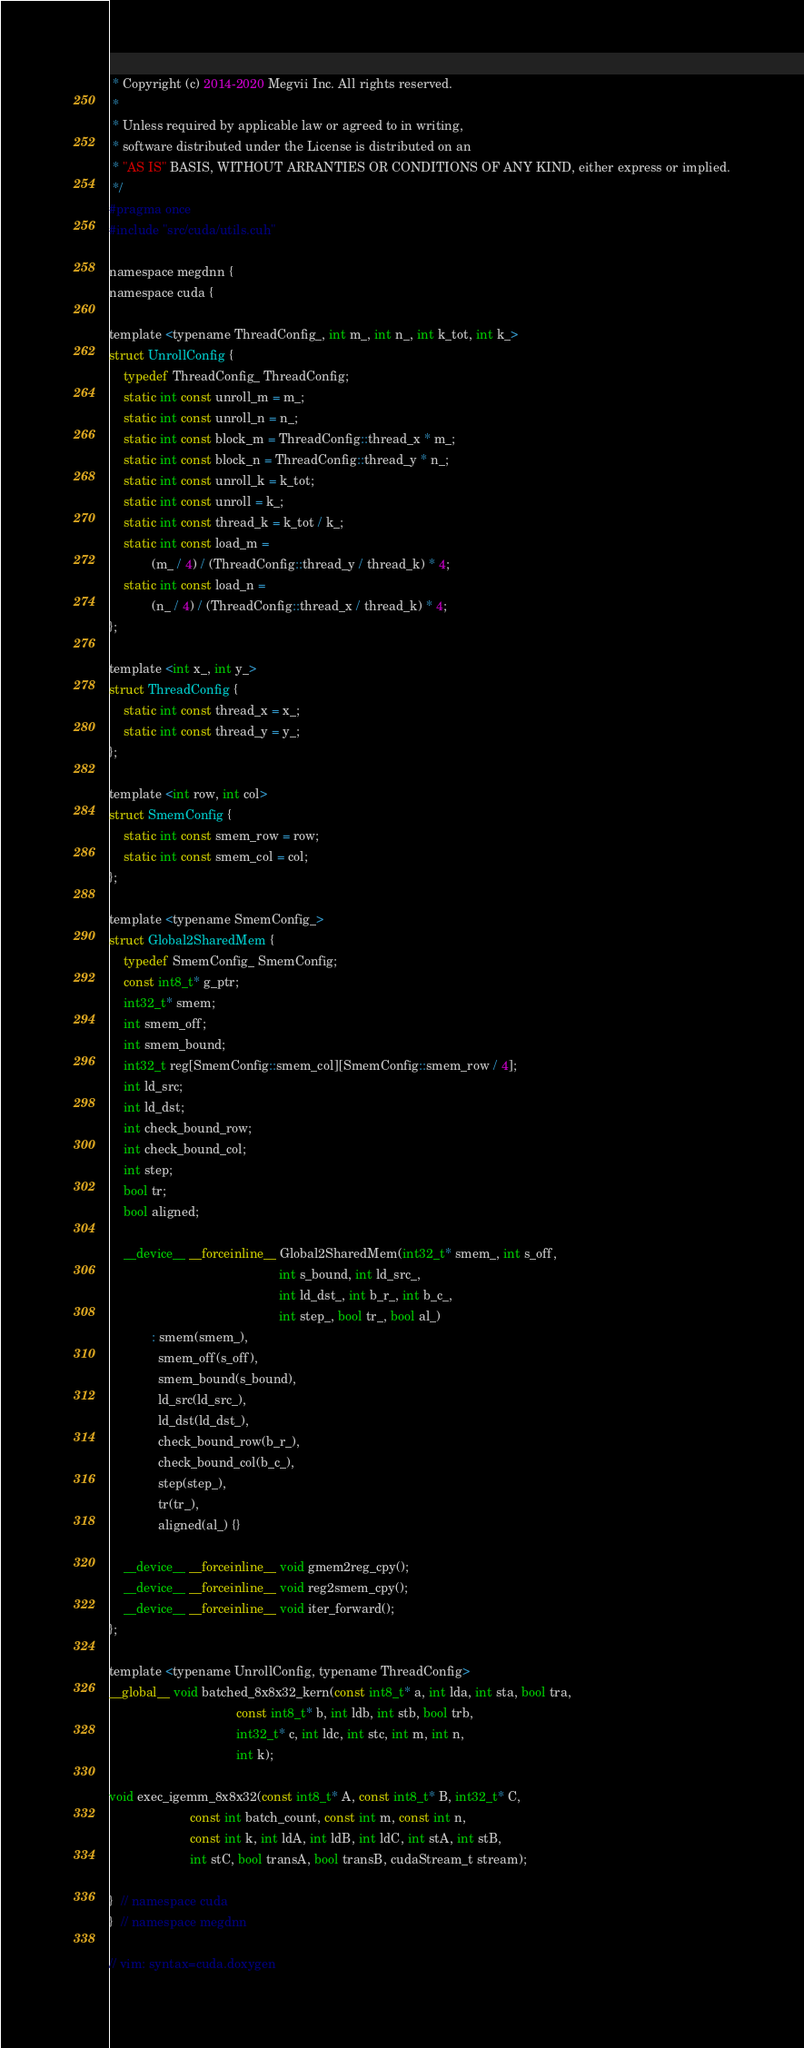Convert code to text. <code><loc_0><loc_0><loc_500><loc_500><_Cuda_> * Copyright (c) 2014-2020 Megvii Inc. All rights reserved.
 *
 * Unless required by applicable law or agreed to in writing,
 * software distributed under the License is distributed on an
 * "AS IS" BASIS, WITHOUT ARRANTIES OR CONDITIONS OF ANY KIND, either express or implied.
 */
#pragma once
#include "src/cuda/utils.cuh"

namespace megdnn {
namespace cuda {

template <typename ThreadConfig_, int m_, int n_, int k_tot, int k_>
struct UnrollConfig {
    typedef ThreadConfig_ ThreadConfig;
    static int const unroll_m = m_;
    static int const unroll_n = n_;
    static int const block_m = ThreadConfig::thread_x * m_;
    static int const block_n = ThreadConfig::thread_y * n_;
    static int const unroll_k = k_tot;
    static int const unroll = k_;
    static int const thread_k = k_tot / k_;
    static int const load_m =
            (m_ / 4) / (ThreadConfig::thread_y / thread_k) * 4;
    static int const load_n =
            (n_ / 4) / (ThreadConfig::thread_x / thread_k) * 4;
};

template <int x_, int y_>
struct ThreadConfig {
    static int const thread_x = x_;
    static int const thread_y = y_;
};

template <int row, int col>
struct SmemConfig {
    static int const smem_row = row;
    static int const smem_col = col;
};

template <typename SmemConfig_>
struct Global2SharedMem {
    typedef SmemConfig_ SmemConfig;
    const int8_t* g_ptr;
    int32_t* smem;
    int smem_off;
    int smem_bound;
    int32_t reg[SmemConfig::smem_col][SmemConfig::smem_row / 4];
    int ld_src;
    int ld_dst;
    int check_bound_row;
    int check_bound_col;
    int step;
    bool tr;
    bool aligned;

    __device__ __forceinline__ Global2SharedMem(int32_t* smem_, int s_off,
                                                int s_bound, int ld_src_,
                                                int ld_dst_, int b_r_, int b_c_,
                                                int step_, bool tr_, bool al_)
            : smem(smem_),
              smem_off(s_off),
              smem_bound(s_bound),
              ld_src(ld_src_),
              ld_dst(ld_dst_),
              check_bound_row(b_r_),
              check_bound_col(b_c_),
              step(step_),
              tr(tr_),
              aligned(al_) {}

    __device__ __forceinline__ void gmem2reg_cpy();
    __device__ __forceinline__ void reg2smem_cpy();
    __device__ __forceinline__ void iter_forward();
};

template <typename UnrollConfig, typename ThreadConfig>
__global__ void batched_8x8x32_kern(const int8_t* a, int lda, int sta, bool tra,
                                    const int8_t* b, int ldb, int stb, bool trb,
                                    int32_t* c, int ldc, int stc, int m, int n,
                                    int k);

void exec_igemm_8x8x32(const int8_t* A, const int8_t* B, int32_t* C,
                       const int batch_count, const int m, const int n,
                       const int k, int ldA, int ldB, int ldC, int stA, int stB,
                       int stC, bool transA, bool transB, cudaStream_t stream);

}  // namespace cuda
}  // namespace megdnn

// vim: syntax=cuda.doxygen
</code> 